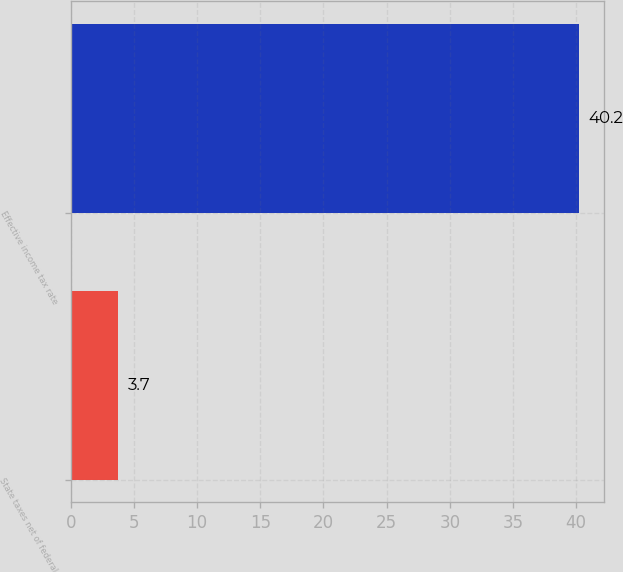Convert chart to OTSL. <chart><loc_0><loc_0><loc_500><loc_500><bar_chart><fcel>State taxes net of federal<fcel>Effective income tax rate<nl><fcel>3.7<fcel>40.2<nl></chart> 